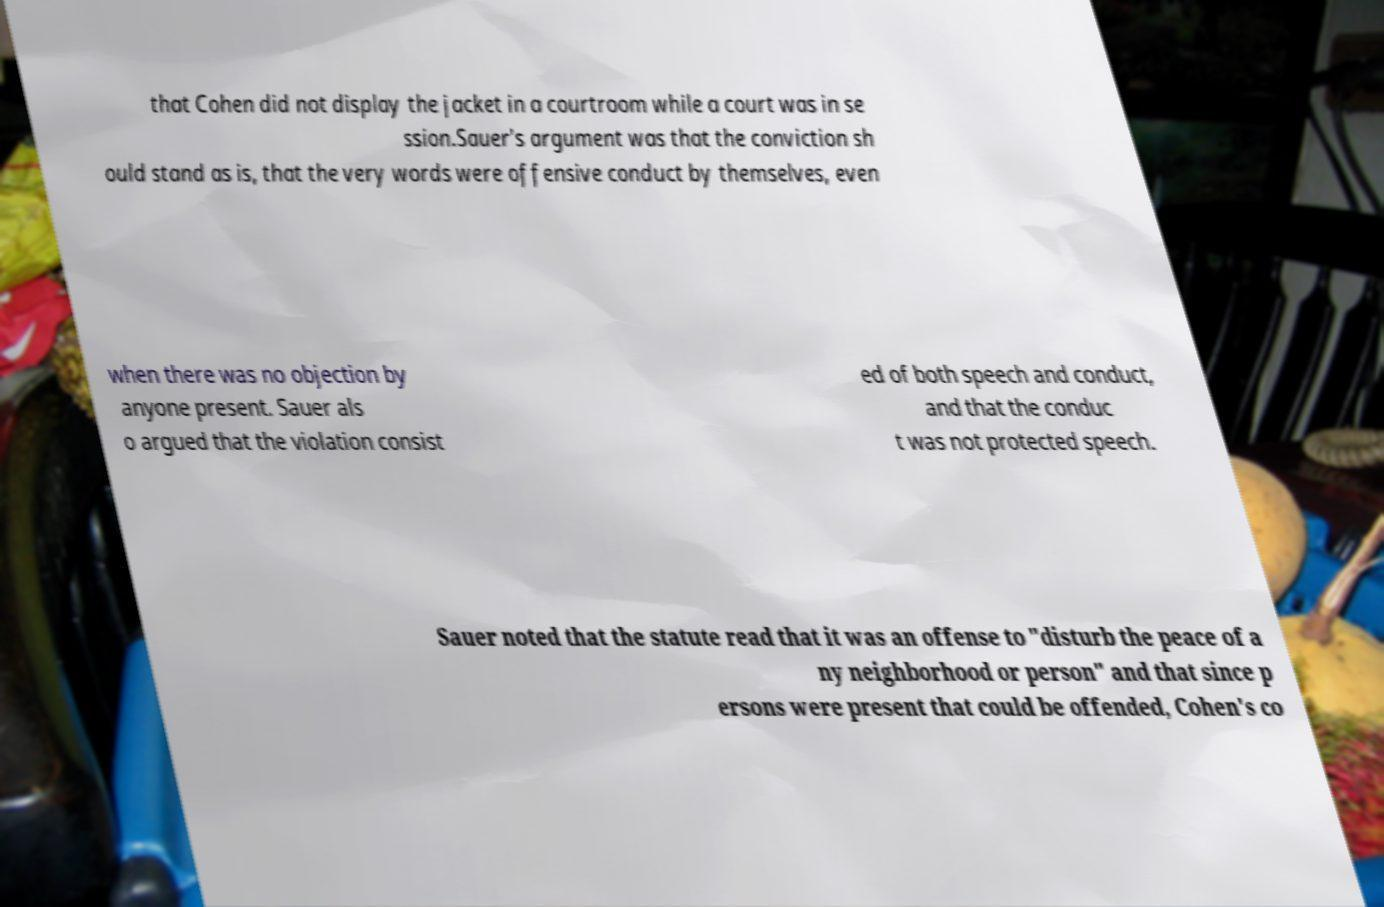Could you extract and type out the text from this image? that Cohen did not display the jacket in a courtroom while a court was in se ssion.Sauer's argument was that the conviction sh ould stand as is, that the very words were offensive conduct by themselves, even when there was no objection by anyone present. Sauer als o argued that the violation consist ed of both speech and conduct, and that the conduc t was not protected speech. Sauer noted that the statute read that it was an offense to "disturb the peace of a ny neighborhood or person" and that since p ersons were present that could be offended, Cohen's co 